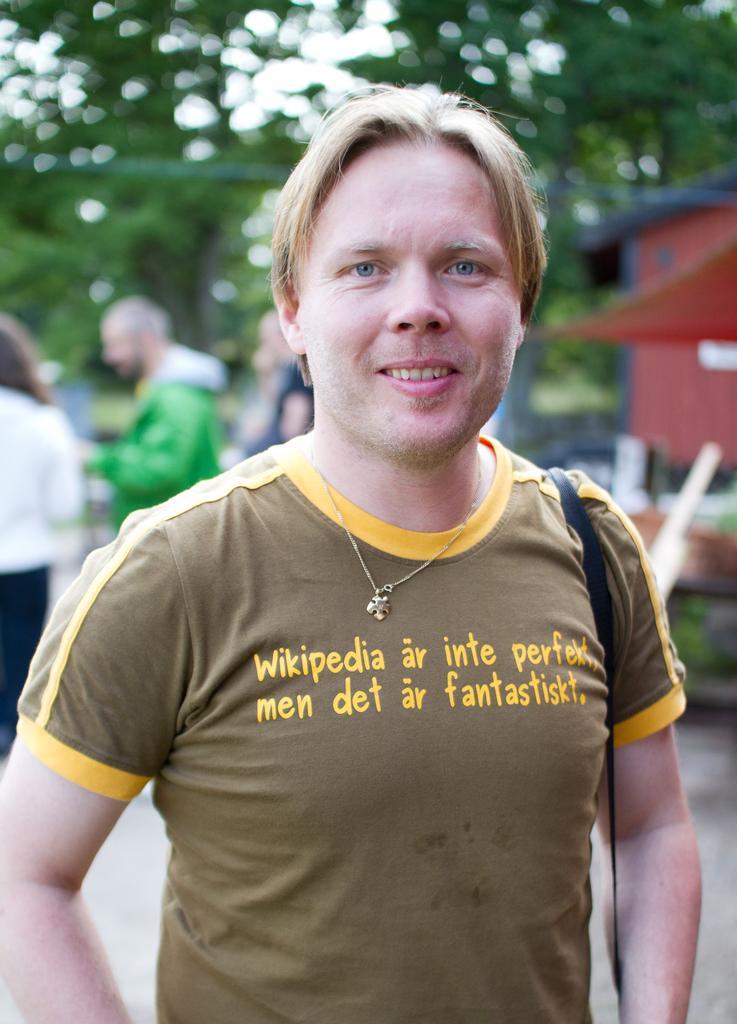Describe this image in one or two sentences. In this image we can see a person standing. And in the background, we can see some other people and the trees. 